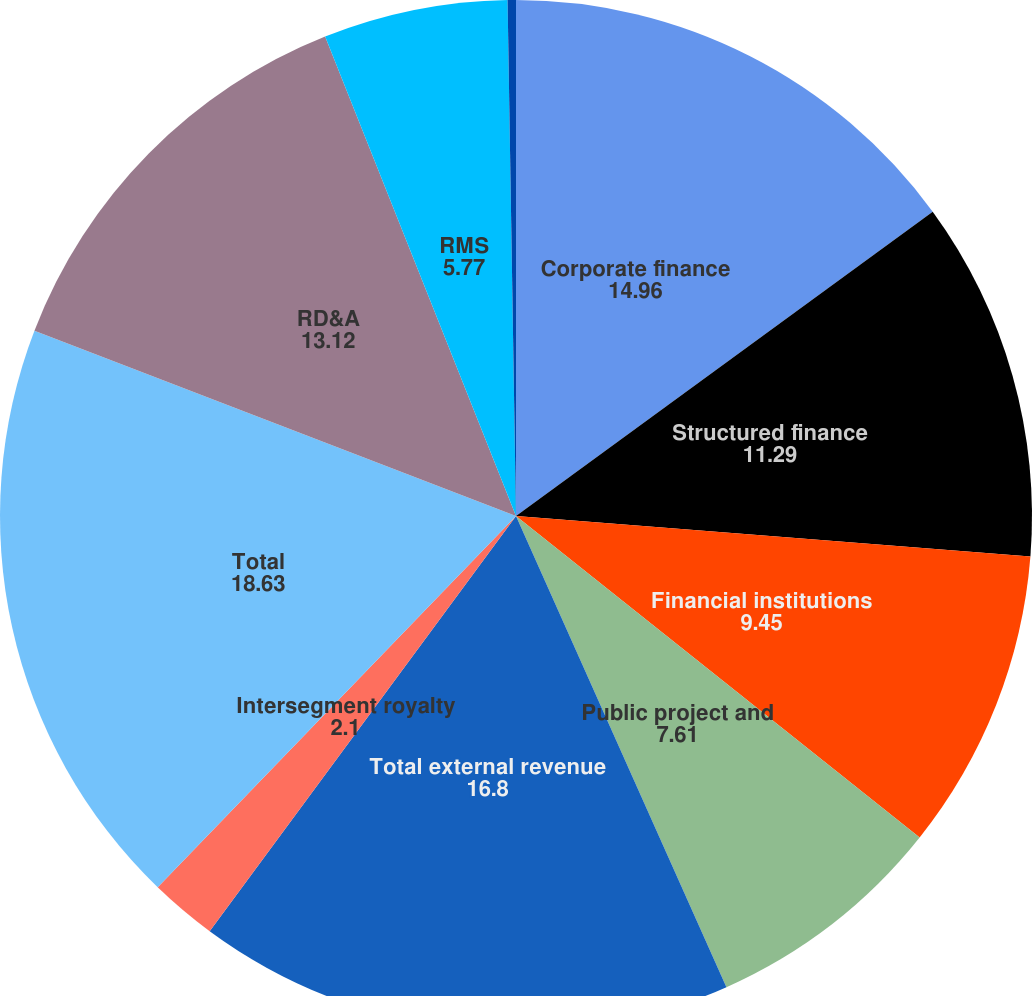Convert chart. <chart><loc_0><loc_0><loc_500><loc_500><pie_chart><fcel>Corporate finance<fcel>Structured finance<fcel>Financial institutions<fcel>Public project and<fcel>Total external revenue<fcel>Intersegment royalty<fcel>Total<fcel>RD&A<fcel>RMS<fcel>Professional services<nl><fcel>14.96%<fcel>11.29%<fcel>9.45%<fcel>7.61%<fcel>16.8%<fcel>2.1%<fcel>18.63%<fcel>13.12%<fcel>5.77%<fcel>0.26%<nl></chart> 